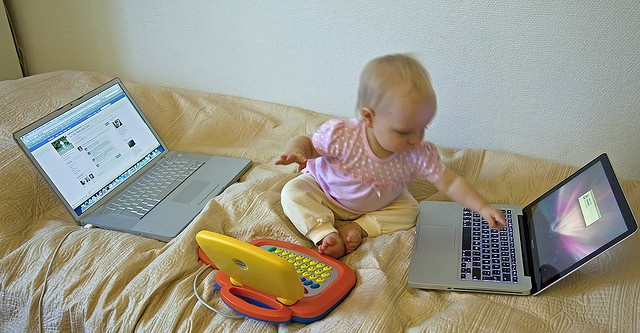Describe the objects in this image and their specific colors. I can see bed in olive, tan, darkgray, and gray tones, people in olive, gray, tan, darkgray, and maroon tones, laptop in olive, lightblue, darkgray, and gray tones, laptop in olive, black, and gray tones, and laptop in olive, brown, and red tones in this image. 